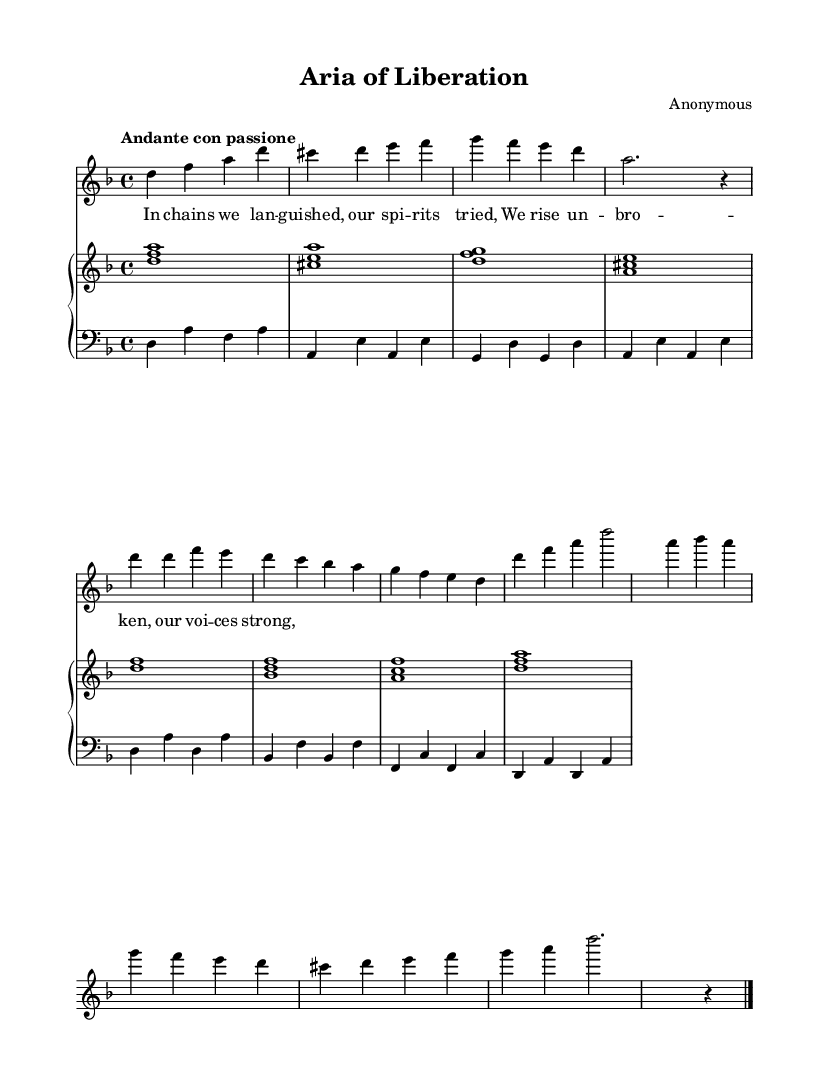What is the key signature of this music? The key signature is indicated right after the clef and shows two flats, which correspond to the key of D minor.
Answer: D minor What is the time signature of this music? The time signature is noted at the beginning of the score, showing that the piece is in 4/4 time, which means there are four beats in each measure.
Answer: 4/4 What is the tempo marking for this aria? The tempo marking appears at the beginning and indicates "Andante con passione," which indicates a moderately slow tempo with passion.
Answer: Andante con passione How many measures are in the refrain section? By counting the measures in the refrain that are distinct from the verses, we see that there are eight measures in total in the refrain section.
Answer: Eight What dynamic marking is indicated for the soprano voice part? The dynamic marking is specified as "dynamicUp," indicating that the vocal line is to be performed with a dynamic that is generally directed upward, suggesting an emphasis on expressiveness.
Answer: Dynamic up What is the function of the piano left hand in this sheet music? The left-hand part in the piano staff serves to provide harmonic support and rhythm to the soprano line by playing bass notes and chords, which complements the melodic line of the voice.
Answer: Harmonic support What theme does the lyric section of the aria express? The lyrics convey a theme of liberation and strength, focusing on resilience and the triumph of the human spirit over oppression.
Answer: Liberation and strength 